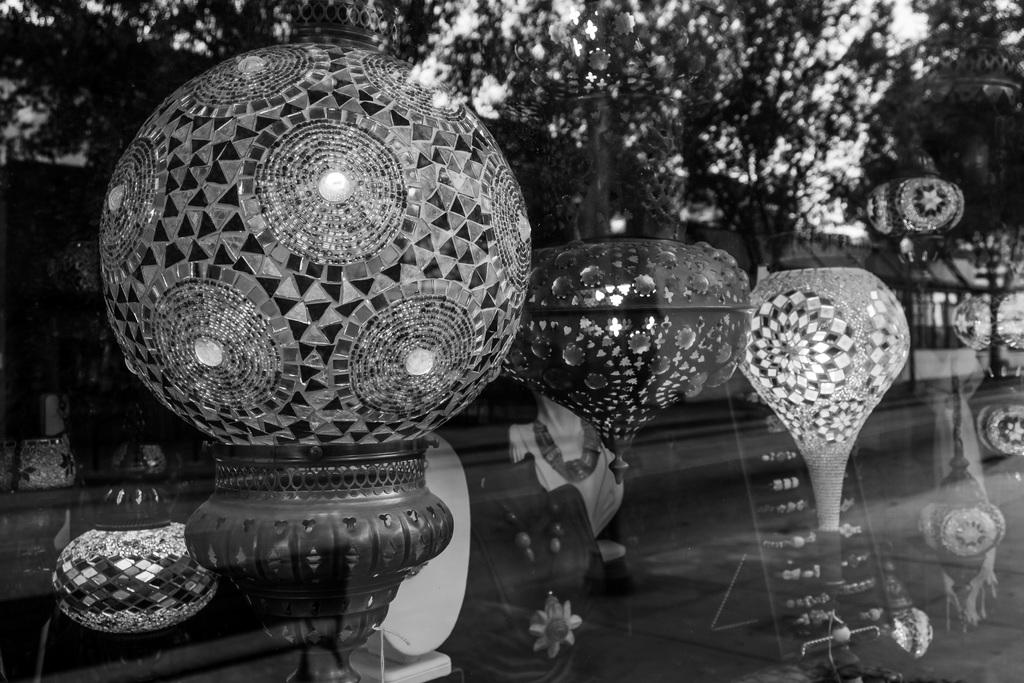What object is present in the image that has a transparent or translucent surface? There is a glass in the image. What can be seen through the glass in the image? Glowing decorative items and other items are visible through the glass. What is the source of the reflection in the glass? The reflection of trees is visible in the glass. What type of statement can be seen written on the corn in the image? There is no corn present in the image, and therefore no statement can be seen written on it. 